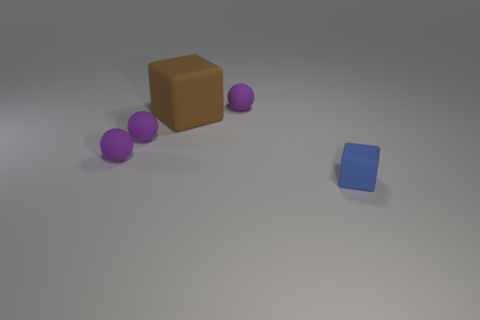There is a large brown thing that is the same material as the tiny blue thing; what is its shape? The large brown object shares the same cubic form as the smaller blue object in the image, featuring distinct flat surfaces and sharp edges that are characteristic of a cube. 